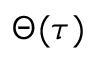<formula> <loc_0><loc_0><loc_500><loc_500>\Theta ( \tau )</formula> 